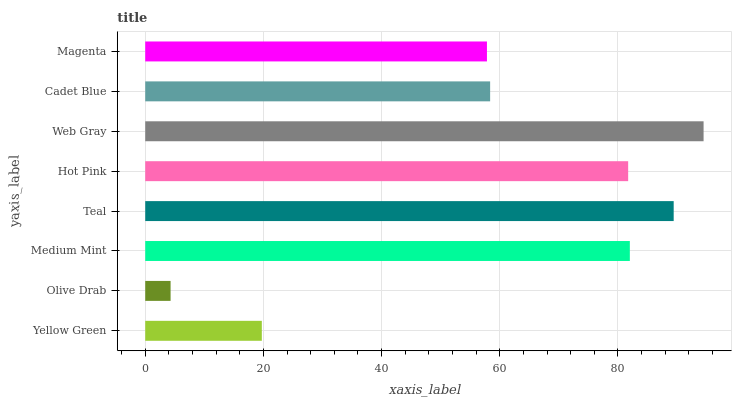Is Olive Drab the minimum?
Answer yes or no. Yes. Is Web Gray the maximum?
Answer yes or no. Yes. Is Medium Mint the minimum?
Answer yes or no. No. Is Medium Mint the maximum?
Answer yes or no. No. Is Medium Mint greater than Olive Drab?
Answer yes or no. Yes. Is Olive Drab less than Medium Mint?
Answer yes or no. Yes. Is Olive Drab greater than Medium Mint?
Answer yes or no. No. Is Medium Mint less than Olive Drab?
Answer yes or no. No. Is Hot Pink the high median?
Answer yes or no. Yes. Is Cadet Blue the low median?
Answer yes or no. Yes. Is Web Gray the high median?
Answer yes or no. No. Is Yellow Green the low median?
Answer yes or no. No. 